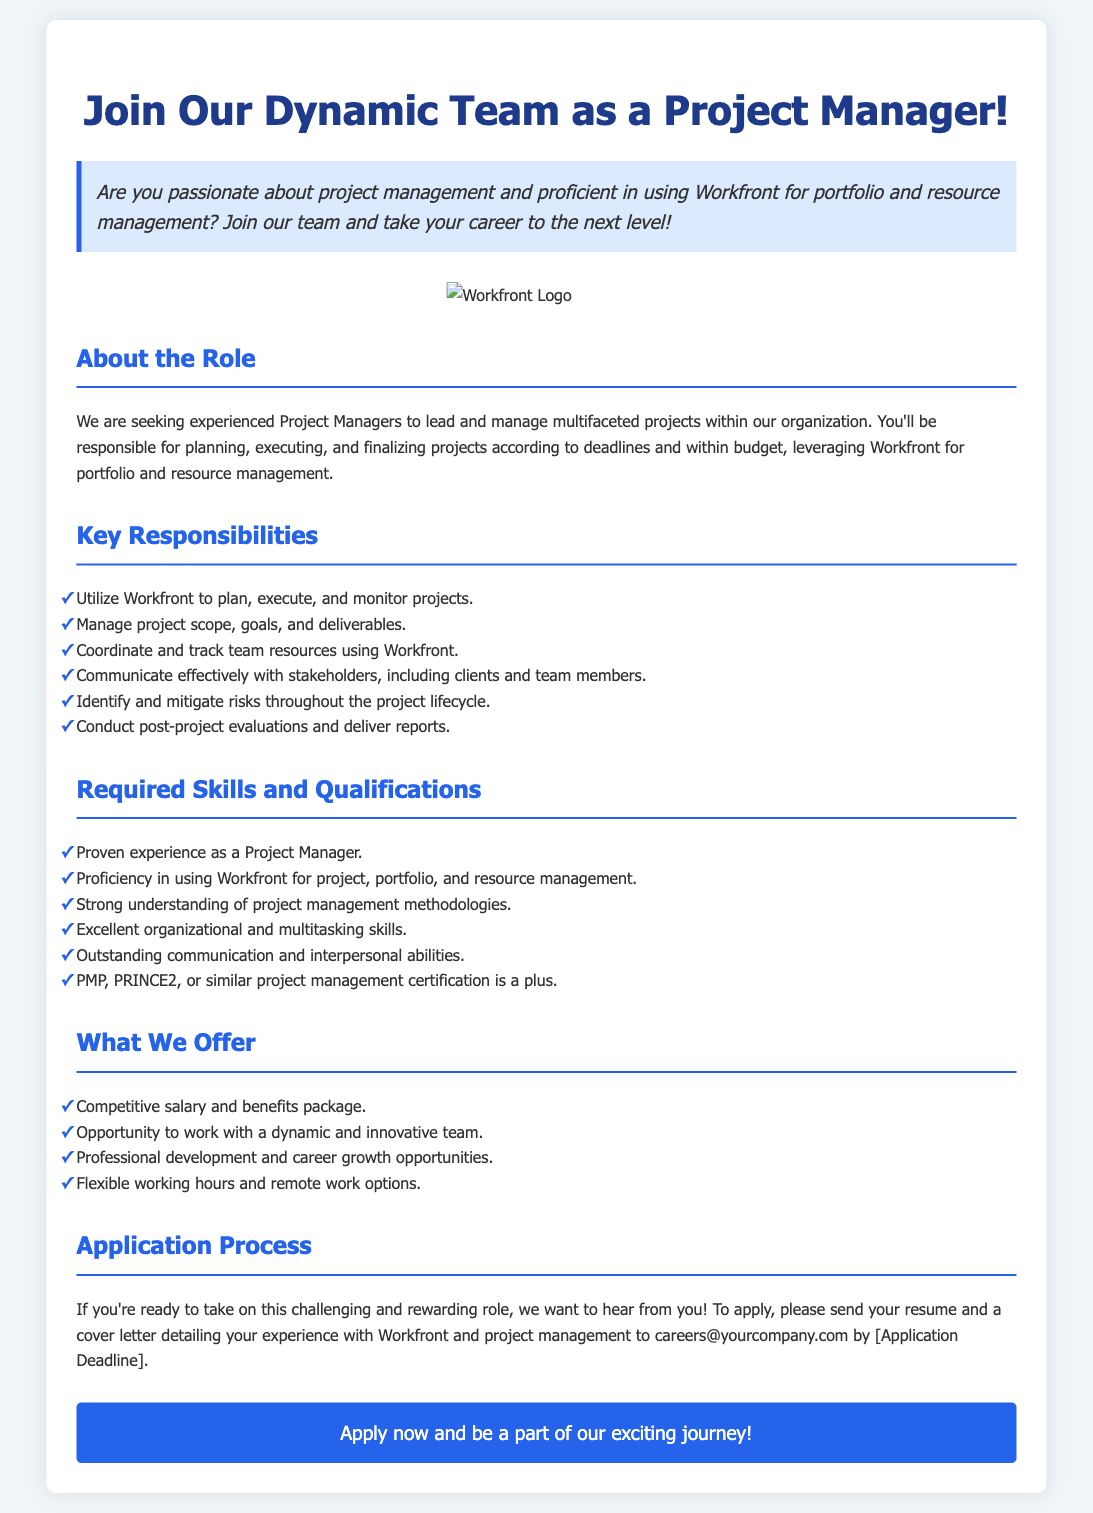What is the title of the advertisement? The title of the advertisement is found in the main header, which captures the position being offered.
Answer: Join Our Dynamic Team as a Project Manager! What is the application deadline? The application deadline is mentioned in the application process section, indicating when applicants should submit their materials.
Answer: [Application Deadline] What is a required skill for the Project Manager position? The required skills are listed under the corresponding section, detailing what candidates need to succeed in the role.
Answer: Proficiency in using Workfront What is one of the key responsibilities of the Project Manager? The responsibilities of the role include specific tasks, highlighting what is expected from candidates in this position.
Answer: Utilize Workfront to plan, execute, and monitor projects What certifications are mentioned as a plus for applicants? The certifications are specifically mentioned in the qualifications section, indicating what may enhance an applicant's profile.
Answer: PMP, PRINCE2 What is one benefit offered to Project Managers? Benefits are outlined, providing insight into what the company offers to attract candidates.
Answer: Competitive salary and benefits package How should interested candidates apply for the position? The application process describes how candidates can submit their application materials.
Answer: Send your resume and a cover letter How many responsibilities are listed for the Project Manager position? The responsibilities are laid out in a specific list format, allowing for easy counting.
Answer: Six responsibilities What type of work options are available for the Project Manager? The benefits section includes information about working arrangements available to employees.
Answer: Flexible working hours and remote work options 